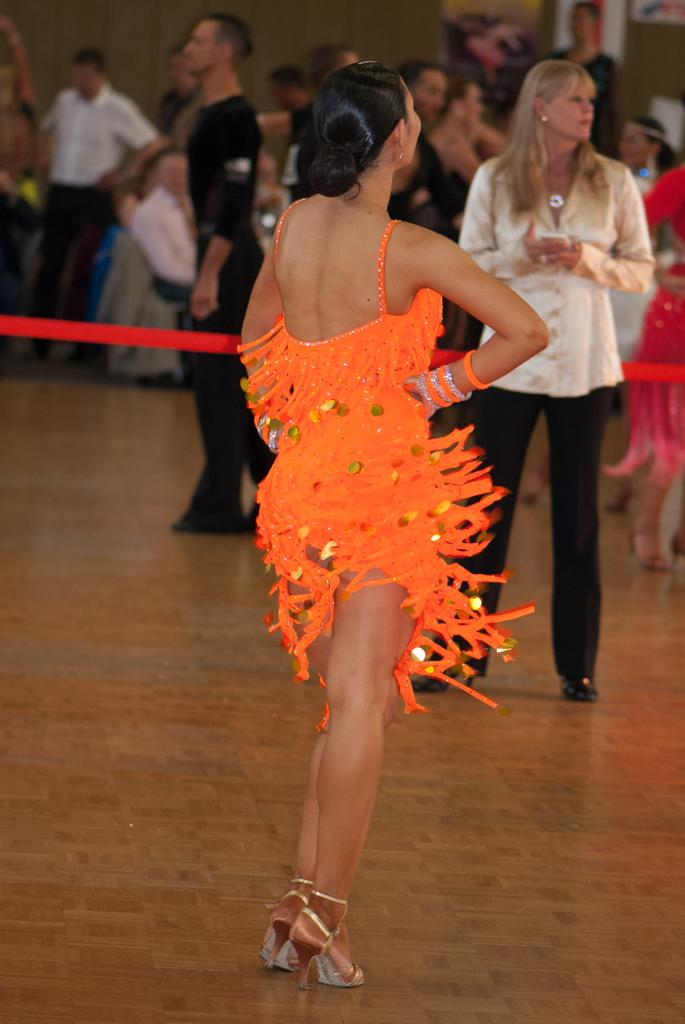How many people are in the image? There are people in the image, specifically a man and two women. What is the man doing in the image? The man is sitting on a chair in the image. What is one of the women doing in the image? One woman is wearing an orange dress and dancing in the image. What can be seen behind the dancing woman? There is a red ribbon behind the dancing woman in the image. Where is the pot located in the image? There is no pot present in the image. Can you see any cats in the image? There are no cats visible in the image. 